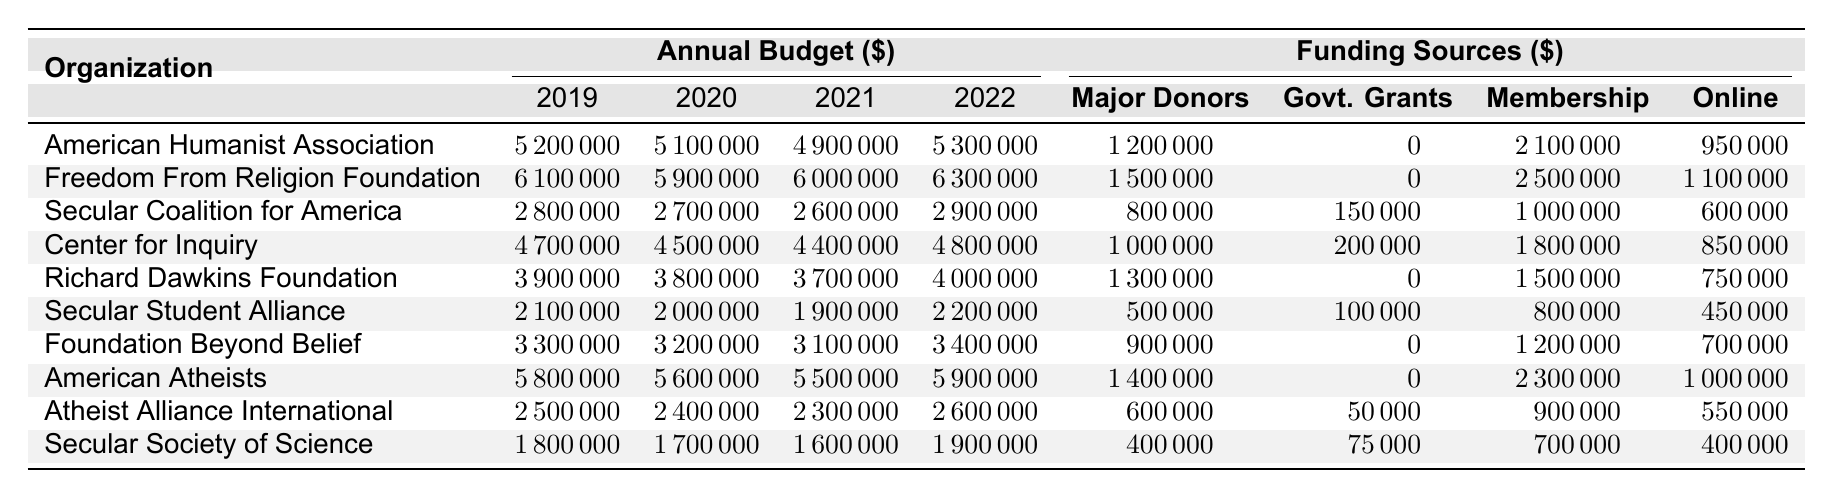What was the budget of the Freedom From Religion Foundation in 2021? The table shows that the budget for the Freedom From Religion Foundation in 2021 is 6,000,000.
Answer: 6,000,000 Which organization had the highest budget in 2022? By checking the budgets for all organizations in 2022, the Freedom From Religion Foundation had the highest budget of 6,300,000.
Answer: Freedom From Religion Foundation What is the total funding from major donors for the American Humanist Association in 2019, 2020, and 2021? The major donor funding for the American Humanist Association in these years is 1,200,000 (2019) + 0 (2020) + 2,100,000 (2021) = 3,300,000.
Answer: 3,300,000 Did the Secular Student Alliance's budget increase or decrease from 2020 to 2021? The budget for Secular Student Alliance in 2020 is 2,000,000 and in 2021 is 1,900,000, indicating a decrease.
Answer: Decrease What are the total government grants received by the Center for Inquiry from 2019 to 2022? The total government grants received by the Center for Inquiry are 200,000 (2019) + 0 (2020) + 150,000 (2021) + 0 (2022) = 350,000.
Answer: 350,000 Which organization had the lowest budget in 2020? In the budget column for 2020, the organization with the lowest budget is the Secular Society of Science with a budget of 1,700,000.
Answer: Secular Society of Science What was the average budget for the Richard Dawkins Foundation from 2019 to 2022? The budgets for the Richard Dawkins Foundation are: 3,900,000 (2019), 3,800,000 (2020), 3,700,000 (2021), and 4,000,000 (2022). The sum is 15,400,000, and dividing by 4 gives an average of 3,850,000.
Answer: 3,850,000 How much did American Atheists generate through online fundraising in 2021? The table indicates that American Atheists generated 1,000,000 through online fundraising in 2021.
Answer: 1,000,000 If we look at all four years, how much did the Secular Coalition for America raise from membership fees? The total from membership fees is 1,000,000 (2019) + 1,000,000 (2020) + 1,000,000 (2021) + 1,000,000 (2022) = 4,000,000.
Answer: 4,000,000 In which year did the Atheist Alliance International see the most significant budget decrease compared to the previous year? The budget for Atheist Alliance International is 2,500,000 in 2019, decreases to 2,400,000 in 2020 (100,000 decrease), and continues to decrease each year, having the steepest decrease from 2,400,000 (2020) to 2,300,000 (2021), which is also a 100,000 decrease.
Answer: 2021 